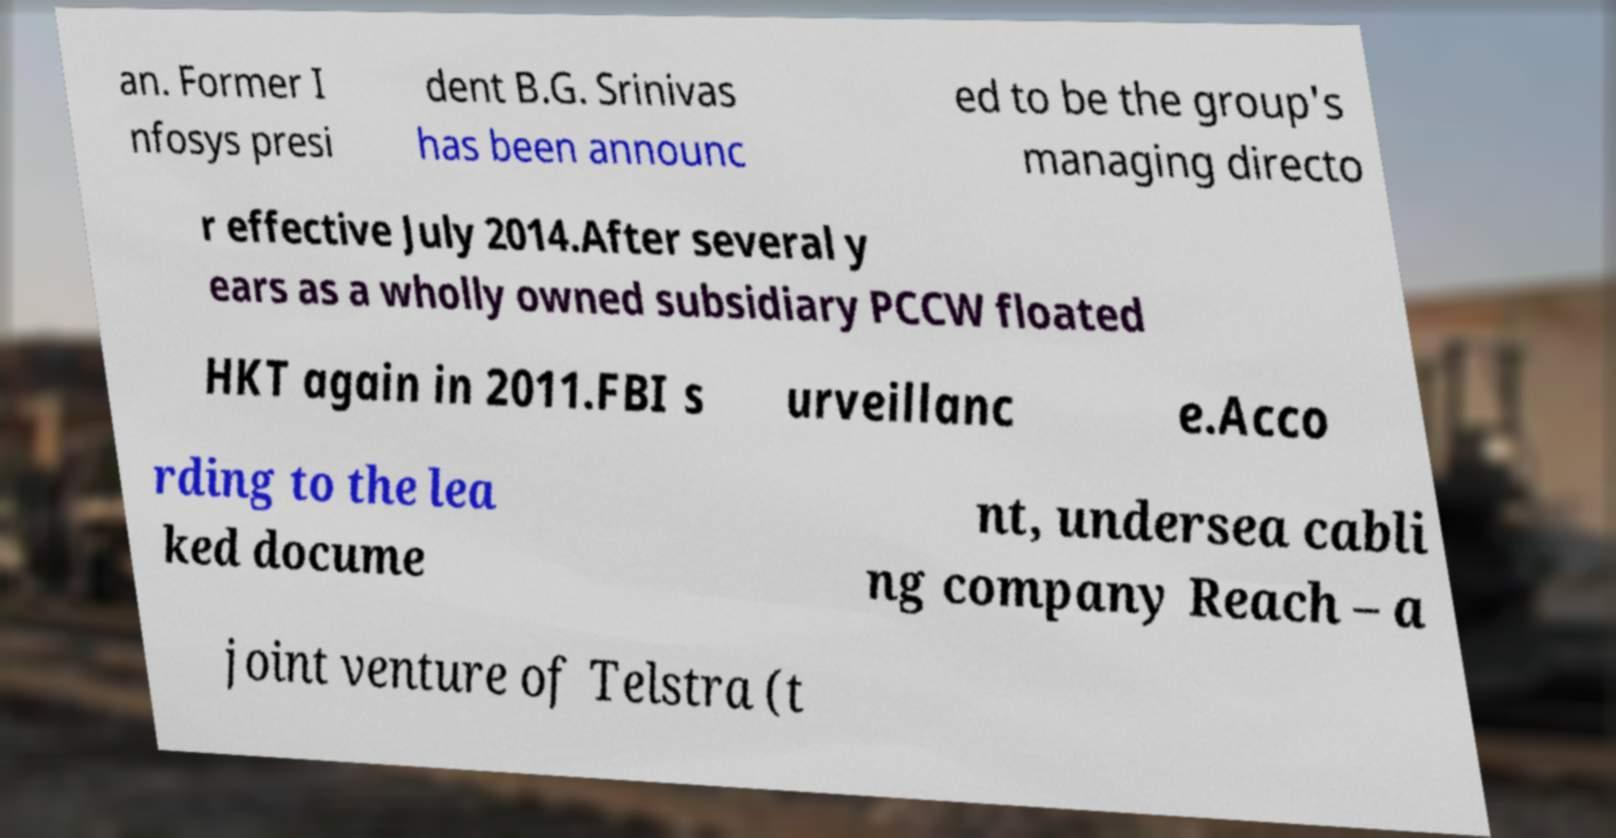Please identify and transcribe the text found in this image. an. Former I nfosys presi dent B.G. Srinivas has been announc ed to be the group's managing directo r effective July 2014.After several y ears as a wholly owned subsidiary PCCW floated HKT again in 2011.FBI s urveillanc e.Acco rding to the lea ked docume nt, undersea cabli ng company Reach – a joint venture of Telstra (t 